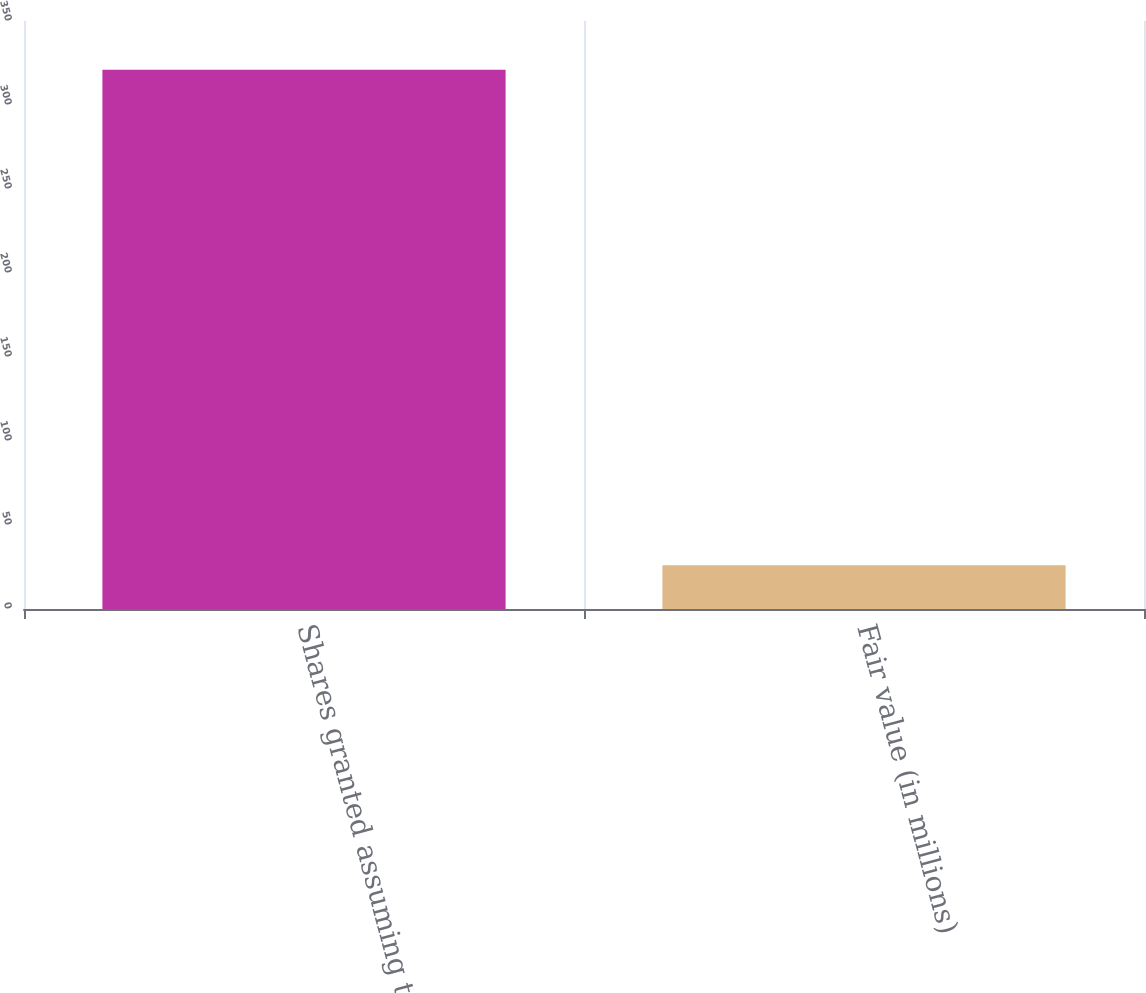Convert chart to OTSL. <chart><loc_0><loc_0><loc_500><loc_500><bar_chart><fcel>Shares granted assuming target<fcel>Fair value (in millions)<nl><fcel>321<fcel>26<nl></chart> 